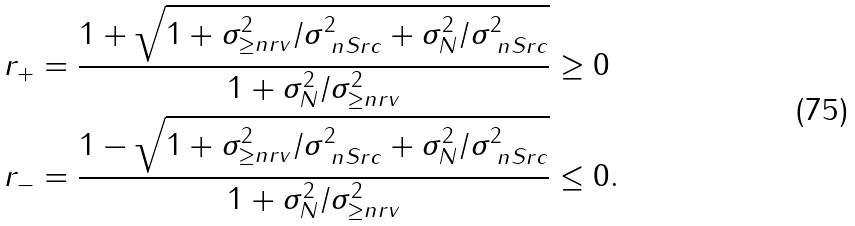<formula> <loc_0><loc_0><loc_500><loc_500>r _ { + } & = \frac { 1 + \sqrt { 1 + \sigma _ { \geq n r v } ^ { 2 } / \sigma _ { \ n S r c } ^ { 2 } + \sigma _ { N } ^ { 2 } / \sigma _ { \ n S r c } ^ { 2 } } } { 1 + \sigma _ { N } ^ { 2 } / \sigma _ { \geq n r v } ^ { 2 } } \geq 0 \\ r _ { - } & = \frac { 1 - \sqrt { 1 + \sigma _ { \geq n r v } ^ { 2 } / \sigma _ { \ n S r c } ^ { 2 } + \sigma _ { N } ^ { 2 } / \sigma _ { \ n S r c } ^ { 2 } } } { 1 + \sigma _ { N } ^ { 2 } / \sigma _ { \geq n r v } ^ { 2 } } \leq 0 .</formula> 